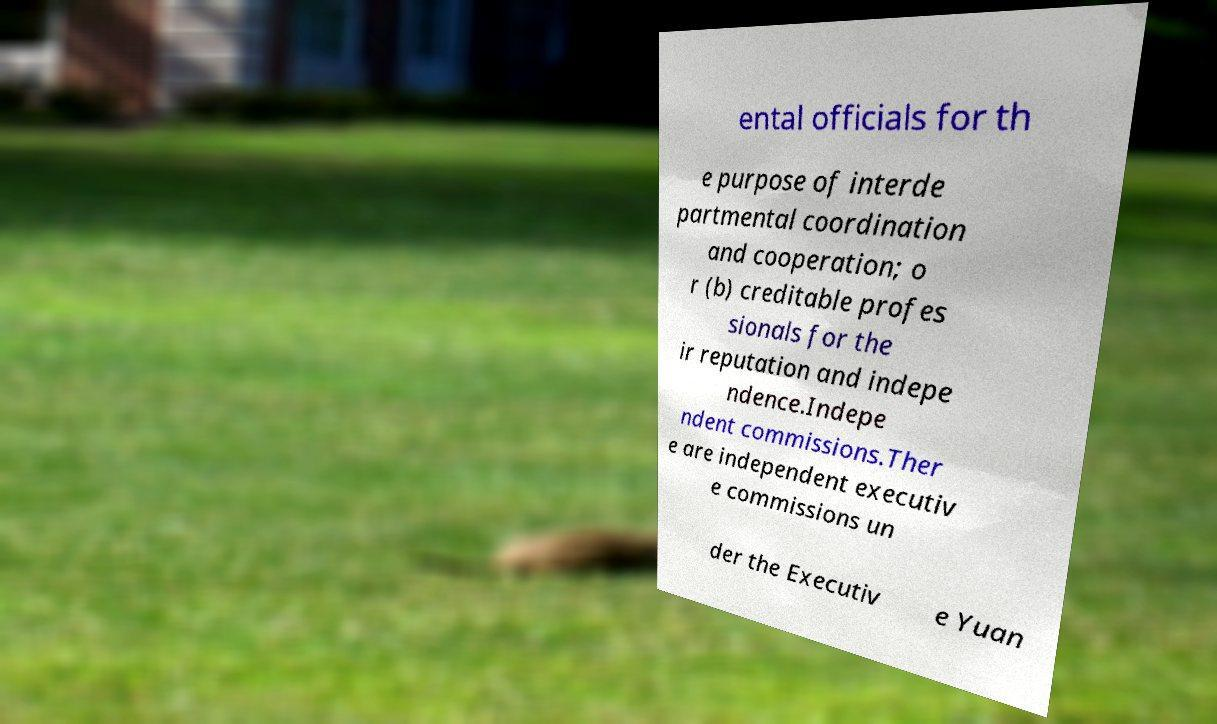Can you accurately transcribe the text from the provided image for me? ental officials for th e purpose of interde partmental coordination and cooperation; o r (b) creditable profes sionals for the ir reputation and indepe ndence.Indepe ndent commissions.Ther e are independent executiv e commissions un der the Executiv e Yuan 